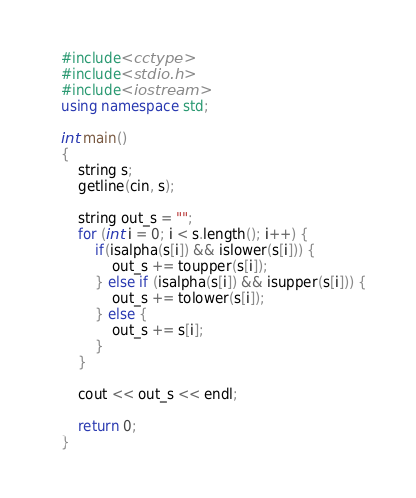Convert code to text. <code><loc_0><loc_0><loc_500><loc_500><_C++_>#include<cctype>
#include<stdio.h>
#include<iostream>
using namespace std;

int main()
{
    string s;
    getline(cin, s);
    
    string out_s = "";
    for (int i = 0; i < s.length(); i++) {
        if(isalpha(s[i]) && islower(s[i])) {
            out_s += toupper(s[i]);
        } else if (isalpha(s[i]) && isupper(s[i])) {
            out_s += tolower(s[i]);
        } else {
            out_s += s[i];
        }
    }
    
    cout << out_s << endl;
    
    return 0;
}
</code> 